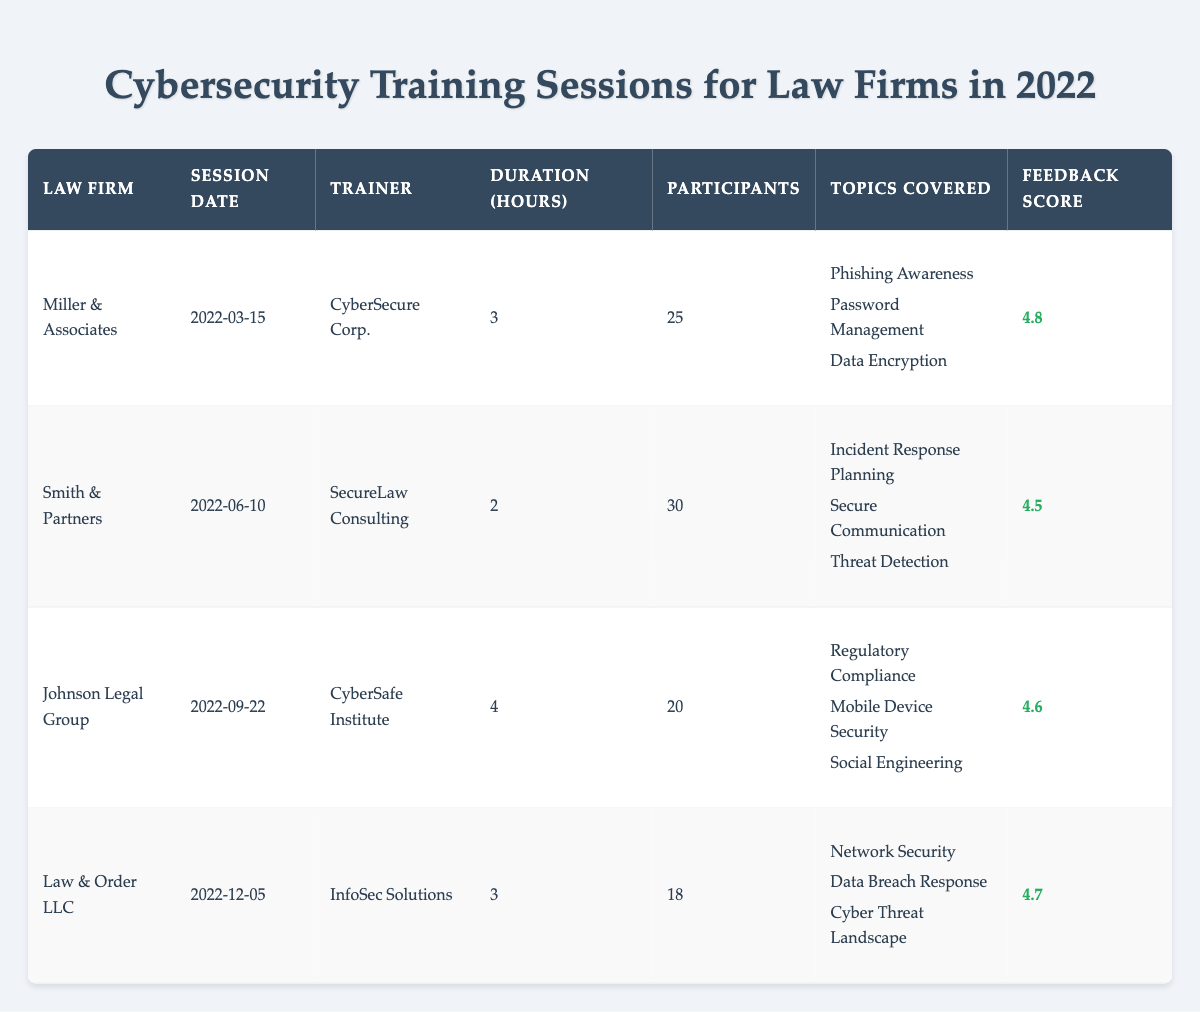What is the feedback score for Miller & Associates? The feedback score for Miller & Associates can be directly found in the table under the "Feedback Score" column, which shows 4.8 for this law firm.
Answer: 4.8 Which law firm had the largest number of participants in their training session? Looking at the "Participants" column, Smith & Partners had the highest number of participants at 30, compared to the 25, 20, and 18 participants for the other law firms.
Answer: Smith & Partners What were the topics covered in the Johnson Legal Group's training session? The table lists the topics covered for each session in the "Topics Covered" column. For Johnson Legal Group, the topics covered were Regulatory Compliance, Mobile Device Security, and Social Engineering.
Answer: Regulatory Compliance, Mobile Device Security, Social Engineering What is the average duration of the training sessions conducted? To find the average duration, we need to add the durations (3 + 2 + 4 + 3 = 12 hours) and then divide by the number of sessions (4). So, 12 hours / 4 sessions = 3 hours.
Answer: 3 hours Did any law firm receive a feedback score below 4.5? By examining the "Feedback Score" column, we see that all firms scored above 4.5, with scores of 4.8, 4.5, 4.6, and 4.7. Therefore, no law firm received a score below 4.5.
Answer: No What law firm had a training session on 'Secure Communication'? The 'Secure Communication' topic is listed under the "Topics Covered" for Smith & Partners. Referring to the table, Smith & Partners is the law firm that covered this topic.
Answer: Smith & Partners Calculate the difference in feedback scores between Miller & Associates and Smith & Partners. The feedback score for Miller & Associates is 4.8, and for Smith & Partners, it's 4.5. Taking the difference, 4.8 - 4.5 = 0.3, we find that Miller & Associates scored 0.3 higher.
Answer: 0.3 How many training sessions covered topics related to Data Security? From the table, Miller & Associates covered "Data Encryption" and Johnson Legal Group covered "Mobile Device Security", while Law & Order LLC covered "Network Security". Therefore, 3 sessions focused on aspects of data security.
Answer: 3 sessions Which trainer conducted the session for Law & Order LLC? The trainer for Law & Order LLC is found in the "Trainer" column, which indicates that the session was conducted by InfoSec Solutions.
Answer: InfoSec Solutions 